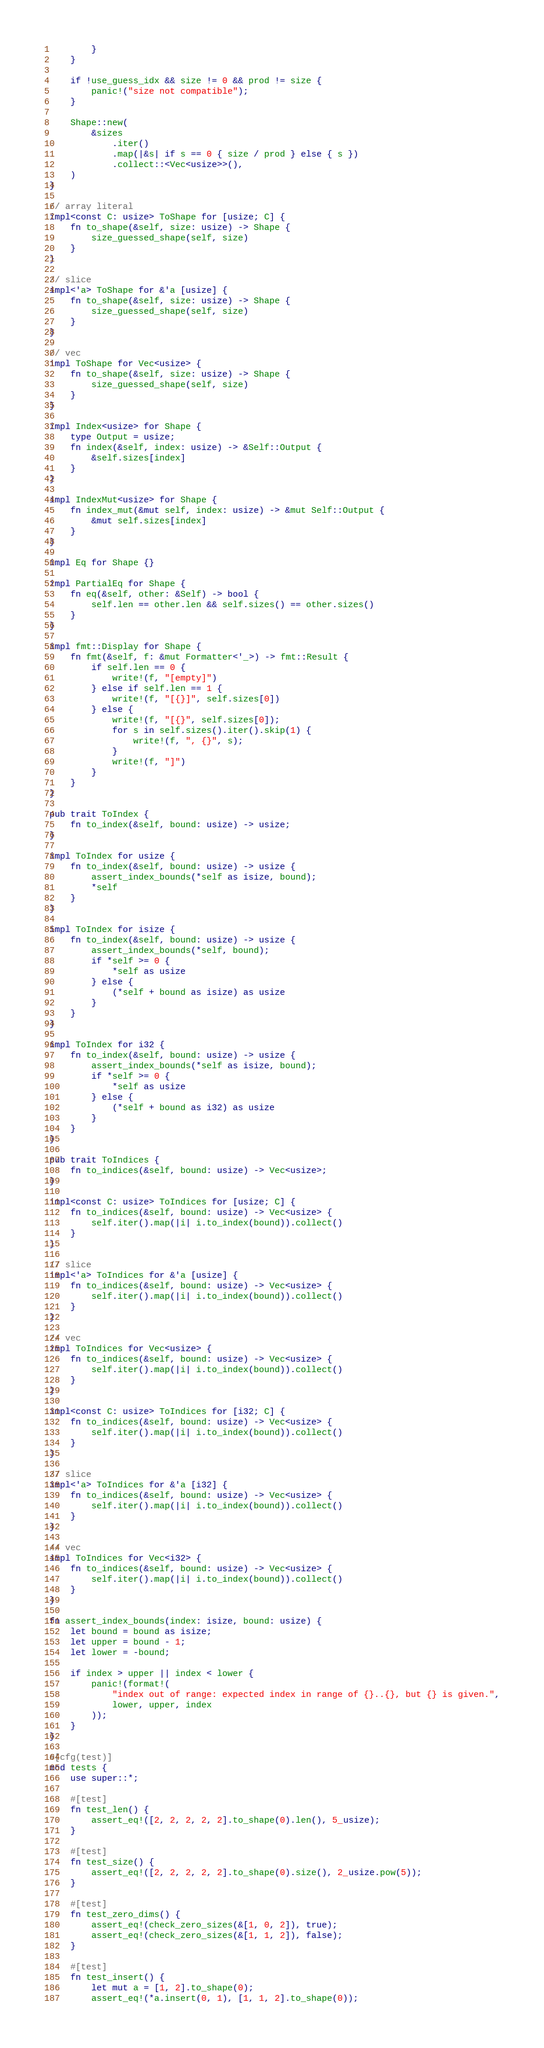Convert code to text. <code><loc_0><loc_0><loc_500><loc_500><_Rust_>        }
    }

    if !use_guess_idx && size != 0 && prod != size {
        panic!("size not compatible");
    }

    Shape::new(
        &sizes
            .iter()
            .map(|&s| if s == 0 { size / prod } else { s })
            .collect::<Vec<usize>>(),
    )
}

// array literal
impl<const C: usize> ToShape for [usize; C] {
    fn to_shape(&self, size: usize) -> Shape {
        size_guessed_shape(self, size)
    }
}

// slice
impl<'a> ToShape for &'a [usize] {
    fn to_shape(&self, size: usize) -> Shape {
        size_guessed_shape(self, size)
    }
}

// vec
impl ToShape for Vec<usize> {
    fn to_shape(&self, size: usize) -> Shape {
        size_guessed_shape(self, size)
    }
}

impl Index<usize> for Shape {
    type Output = usize;
    fn index(&self, index: usize) -> &Self::Output {
        &self.sizes[index]
    }
}

impl IndexMut<usize> for Shape {
    fn index_mut(&mut self, index: usize) -> &mut Self::Output {
        &mut self.sizes[index]
    }
}

impl Eq for Shape {}

impl PartialEq for Shape {
    fn eq(&self, other: &Self) -> bool {
        self.len == other.len && self.sizes() == other.sizes()
    }
}

impl fmt::Display for Shape {
    fn fmt(&self, f: &mut Formatter<'_>) -> fmt::Result {
        if self.len == 0 {
            write!(f, "[empty]")
        } else if self.len == 1 {
            write!(f, "[{}]", self.sizes[0])
        } else {
            write!(f, "[{}", self.sizes[0]);
            for s in self.sizes().iter().skip(1) {
                write!(f, ", {}", s);
            }
            write!(f, "]")
        }
    }
}

pub trait ToIndex {
    fn to_index(&self, bound: usize) -> usize;
}

impl ToIndex for usize {
    fn to_index(&self, bound: usize) -> usize {
        assert_index_bounds(*self as isize, bound);
        *self
    }
}

impl ToIndex for isize {
    fn to_index(&self, bound: usize) -> usize {
        assert_index_bounds(*self, bound);
        if *self >= 0 {
            *self as usize
        } else {
            (*self + bound as isize) as usize
        }
    }
}

impl ToIndex for i32 {
    fn to_index(&self, bound: usize) -> usize {
        assert_index_bounds(*self as isize, bound);
        if *self >= 0 {
            *self as usize
        } else {
            (*self + bound as i32) as usize
        }
    }
}

pub trait ToIndices {
    fn to_indices(&self, bound: usize) -> Vec<usize>;
}

impl<const C: usize> ToIndices for [usize; C] {
    fn to_indices(&self, bound: usize) -> Vec<usize> {
        self.iter().map(|i| i.to_index(bound)).collect()
    }
}

// slice
impl<'a> ToIndices for &'a [usize] {
    fn to_indices(&self, bound: usize) -> Vec<usize> {
        self.iter().map(|i| i.to_index(bound)).collect()
    }
}

// vec
impl ToIndices for Vec<usize> {
    fn to_indices(&self, bound: usize) -> Vec<usize> {
        self.iter().map(|i| i.to_index(bound)).collect()
    }
}

impl<const C: usize> ToIndices for [i32; C] {
    fn to_indices(&self, bound: usize) -> Vec<usize> {
        self.iter().map(|i| i.to_index(bound)).collect()
    }
}

// slice
impl<'a> ToIndices for &'a [i32] {
    fn to_indices(&self, bound: usize) -> Vec<usize> {
        self.iter().map(|i| i.to_index(bound)).collect()
    }
}

// vec
impl ToIndices for Vec<i32> {
    fn to_indices(&self, bound: usize) -> Vec<usize> {
        self.iter().map(|i| i.to_index(bound)).collect()
    }
}

fn assert_index_bounds(index: isize, bound: usize) {
    let bound = bound as isize;
    let upper = bound - 1;
    let lower = -bound;

    if index > upper || index < lower {
        panic!(format!(
            "index out of range: expected index in range of {}..{}, but {} is given.",
            lower, upper, index
        ));
    }
}

#[cfg(test)]
mod tests {
    use super::*;

    #[test]
    fn test_len() {
        assert_eq!([2, 2, 2, 2, 2].to_shape(0).len(), 5_usize);
    }

    #[test]
    fn test_size() {
        assert_eq!([2, 2, 2, 2, 2].to_shape(0).size(), 2_usize.pow(5));
    }

    #[test]
    fn test_zero_dims() {
        assert_eq!(check_zero_sizes(&[1, 0, 2]), true);
        assert_eq!(check_zero_sizes(&[1, 1, 2]), false);
    }

    #[test]
    fn test_insert() {
        let mut a = [1, 2].to_shape(0);
        assert_eq!(*a.insert(0, 1), [1, 1, 2].to_shape(0));</code> 